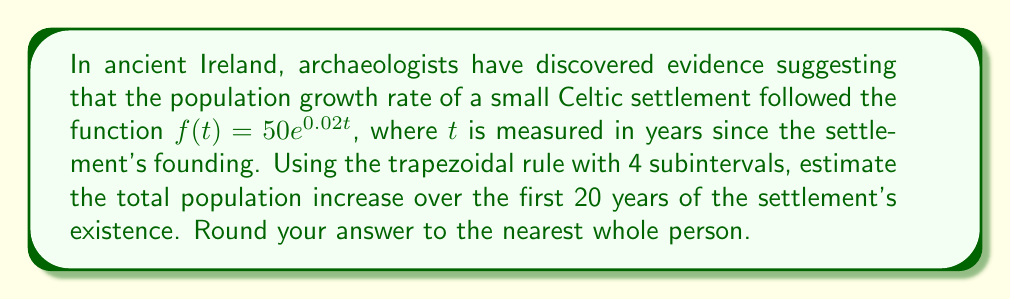Help me with this question. To solve this problem, we'll use the trapezoidal rule for numerical integration. The steps are as follows:

1) The definite integral we need to calculate is:

   $$\int_{0}^{20} 50e^{0.02t} dt$$

2) For the trapezoidal rule with 4 subintervals, we need to divide the interval [0, 20] into 4 equal parts. The width of each subinterval is:

   $$h = \frac{20 - 0}{4} = 5$$

3) We need to evaluate the function at t = 0, 5, 10, 15, and 20:

   $f(0) = 50e^{0} = 50$
   $f(5) = 50e^{0.1} \approx 55.27$
   $f(10) = 50e^{0.2} \approx 61.10$
   $f(15) = 50e^{0.3} \approx 67.53$
   $f(20) = 50e^{0.4} \approx 74.66$

4) The trapezoidal rule formula is:

   $$\int_{a}^{b} f(x) dx \approx \frac{h}{2}[f(x_0) + 2f(x_1) + 2f(x_2) + ... + 2f(x_{n-1}) + f(x_n)]$$

5) Plugging in our values:

   $$\int_{0}^{20} 50e^{0.02t} dt \approx \frac{5}{2}[50 + 2(55.27) + 2(61.10) + 2(67.53) + 74.66]$$

6) Calculating:

   $$\approx 2.5[50 + 110.54 + 122.20 + 135.06 + 74.66]$$
   $$\approx 2.5[492.46]$$
   $$\approx 1231.15$$

7) Rounding to the nearest whole person:

   1231 people
Answer: 1231 people 